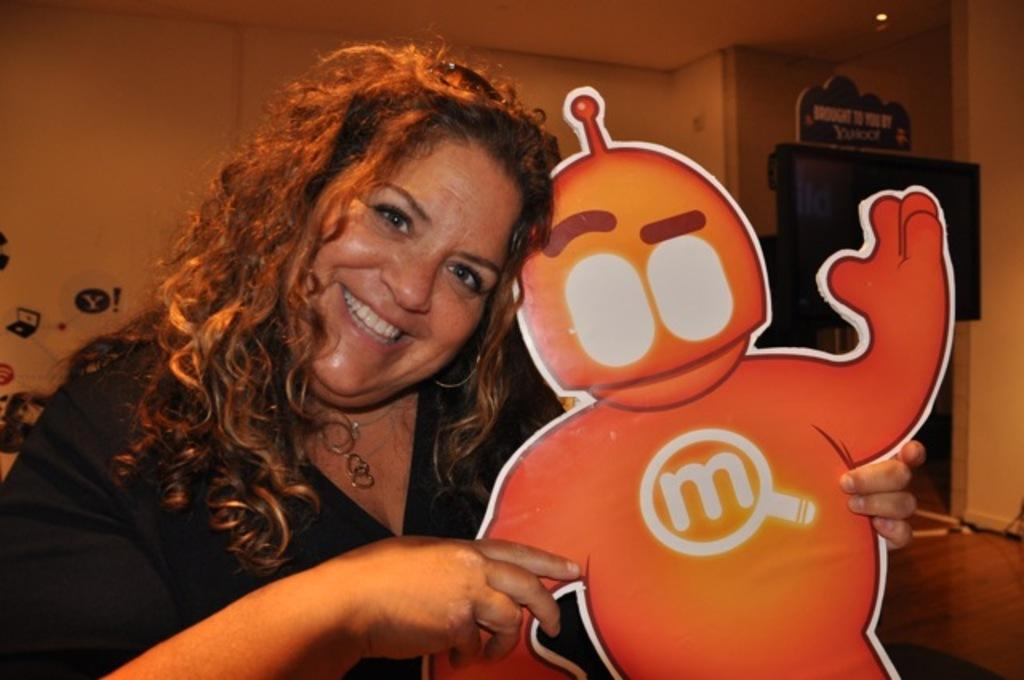<image>
Share a concise interpretation of the image provided. A woman holds a cardboard cutout of an orange robot with the letter "M" on it. 